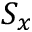Convert formula to latex. <formula><loc_0><loc_0><loc_500><loc_500>S _ { x }</formula> 